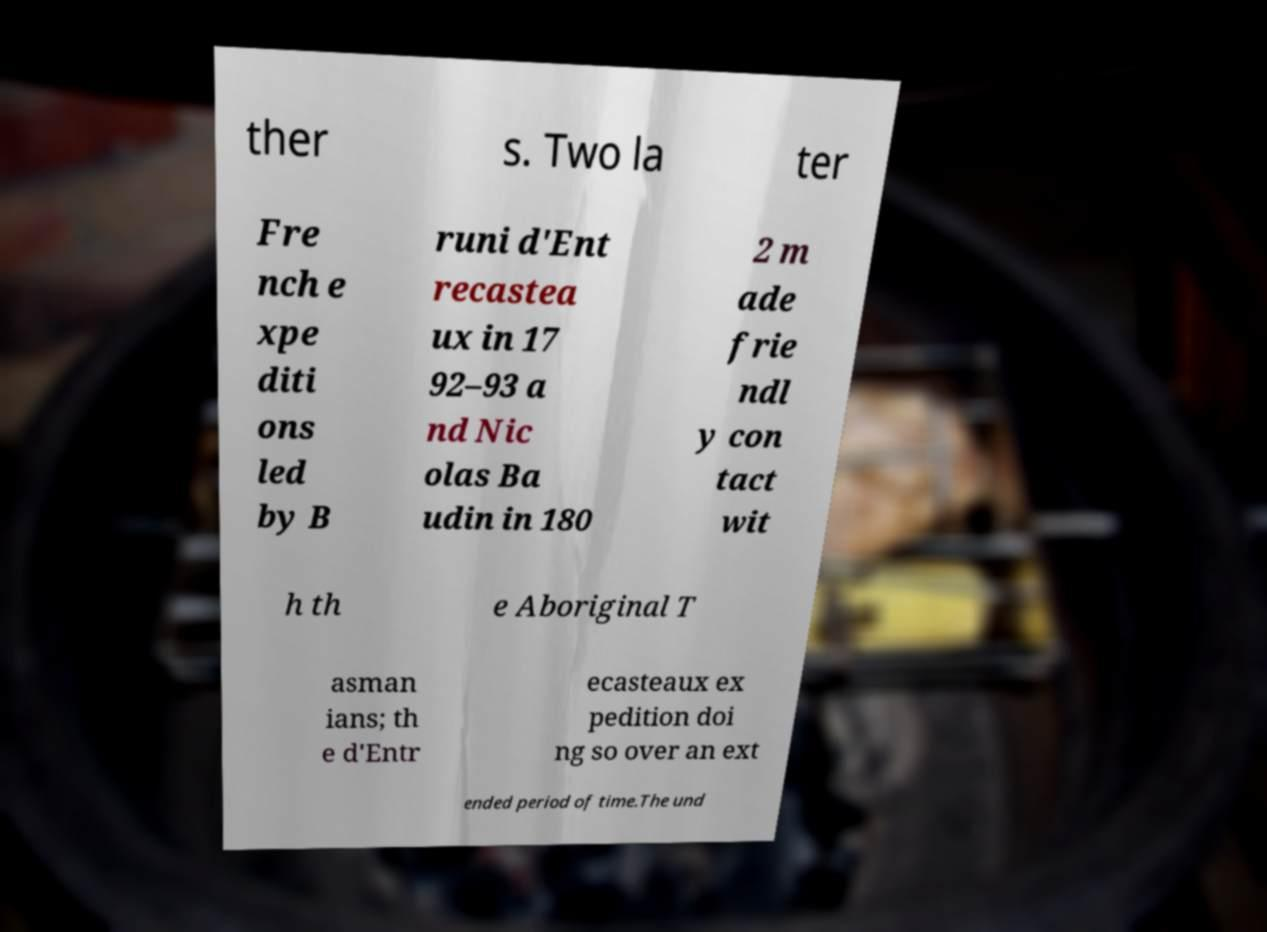Please identify and transcribe the text found in this image. ther s. Two la ter Fre nch e xpe diti ons led by B runi d'Ent recastea ux in 17 92–93 a nd Nic olas Ba udin in 180 2 m ade frie ndl y con tact wit h th e Aboriginal T asman ians; th e d'Entr ecasteaux ex pedition doi ng so over an ext ended period of time.The und 